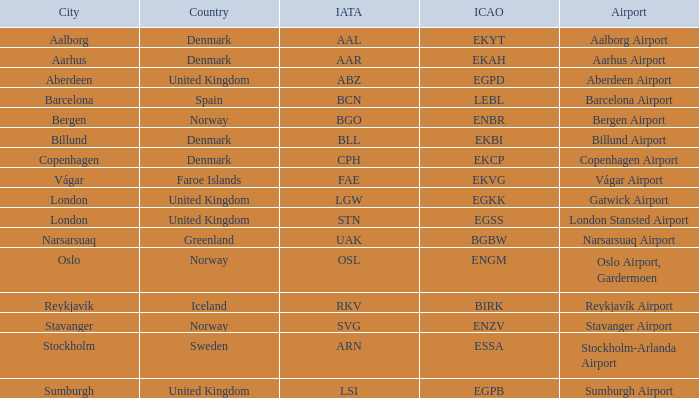What airport has an ICAO of Birk? Reykjavík Airport. 